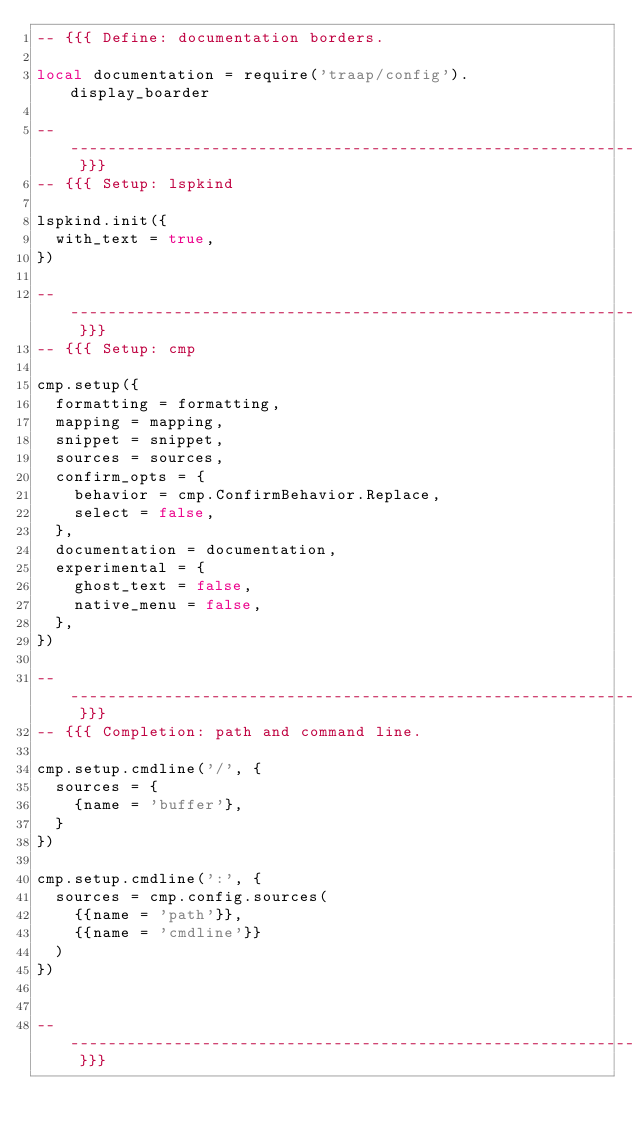Convert code to text. <code><loc_0><loc_0><loc_500><loc_500><_Lua_>-- {{{ Define: documentation borders.

local documentation = require('traap/config').display_boarder

-- ------------------------------------------------------------------------- }}}
-- {{{ Setup: lspkind

lspkind.init({
  with_text = true,
})

-- ------------------------------------------------------------------------- }}}
-- {{{ Setup: cmp

cmp.setup({
  formatting = formatting,
  mapping = mapping,
  snippet = snippet,
  sources = sources,
  confirm_opts = {
    behavior = cmp.ConfirmBehavior.Replace,
    select = false,
  },
  documentation = documentation,
  experimental = {
    ghost_text = false,
    native_menu = false,
  },
})

-- ------------------------------------------------------------------------- }}}
-- {{{ Completion: path and command line.

cmp.setup.cmdline('/', {
  sources = {
    {name = 'buffer'},
  }
})

cmp.setup.cmdline(':', {
  sources = cmp.config.sources(
    {{name = 'path'}},
    {{name = 'cmdline'}}
  )
})


-- ------------------------------------------------------------------------- }}}
</code> 